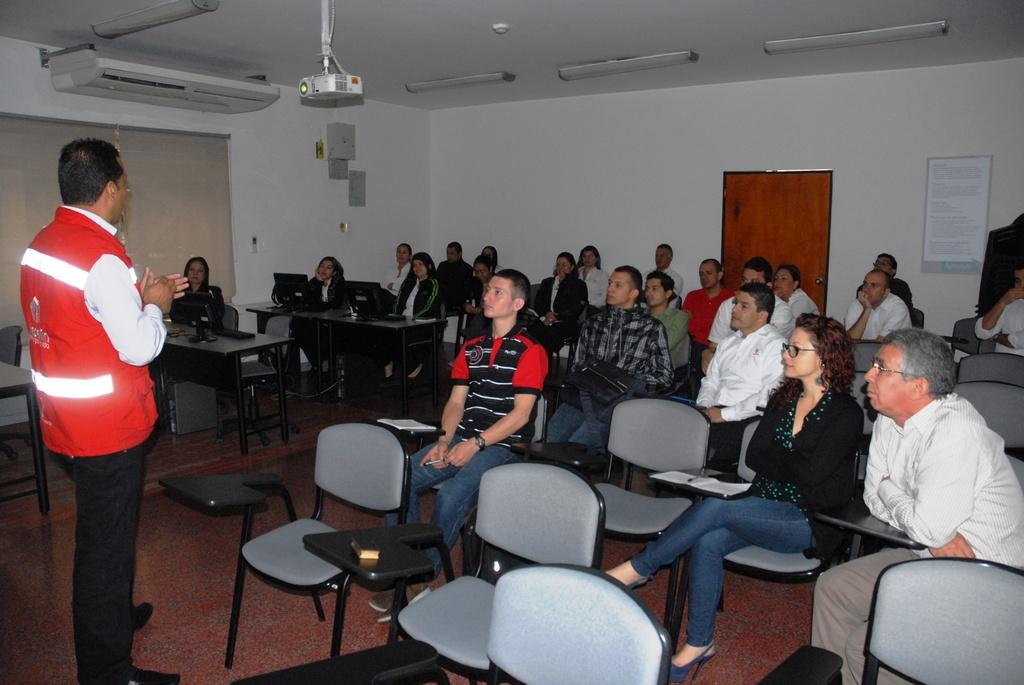What is the position of the person in the image? There is a person standing on the left side of the image. What is the person doing in the image? The person is speaking. Who is the person addressing in the image? There are people in front of the person. What can be seen in the background of the image? There is a door in the background of the image. What is the color of the wall in the image? The wall is white in color. What type of skin is visible on the person's hands in the image? There is no information about the person's hands or skin in the image. Can you tell me how many crackers are on the table in the image? There is no table or crackers present in the image. 